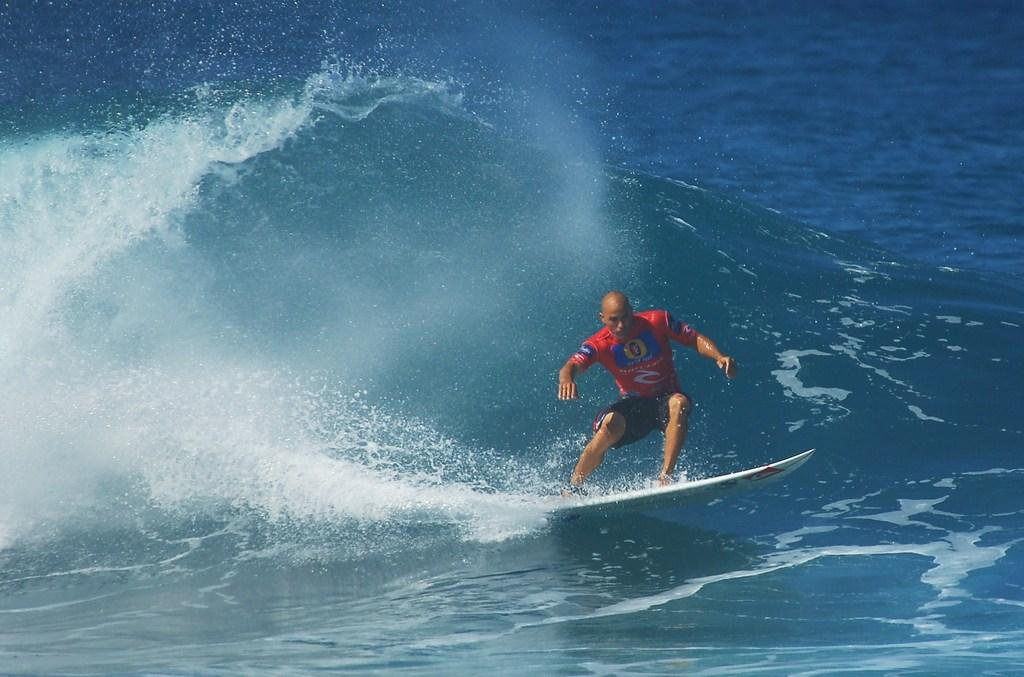What is the primary element in the image? There is water in the image. What activity is the person in the image engaged in? A person is moving on a surfboard in the water. What type of servant can be seen assisting the person on the surfboard in the image? There is no servant present in the image; it only shows a person surfing on a surfboard in the water. 